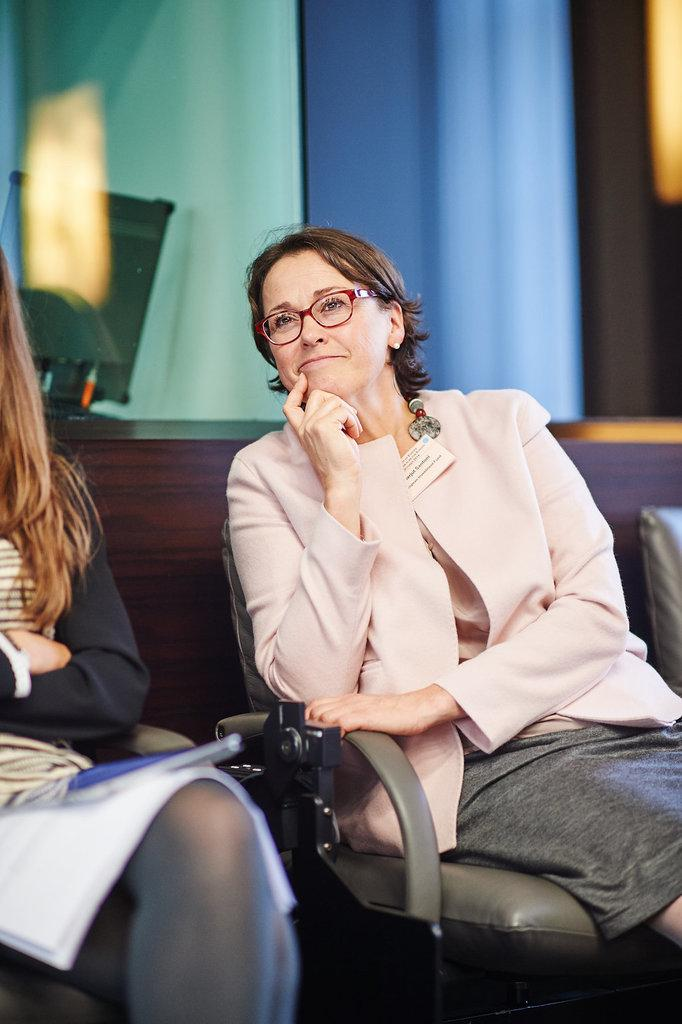How many people are sitting in the image? There are two people sitting on chairs in the image. Can you describe the woman in the image? The woman is wearing spectacles and smiling. What can be seen in the background of the image? There is a wall visible in the background of the image, and there are objects present as well. How many geese are flying over the woman's head in the image? There are no geese present in the image; it only features two people sitting on chairs. 